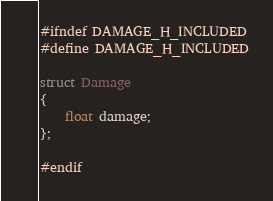Convert code to text. <code><loc_0><loc_0><loc_500><loc_500><_C_>#ifndef DAMAGE_H_INCLUDED
#define DAMAGE_H_INCLUDED

struct Damage
{
    float damage;
};

#endif
</code> 